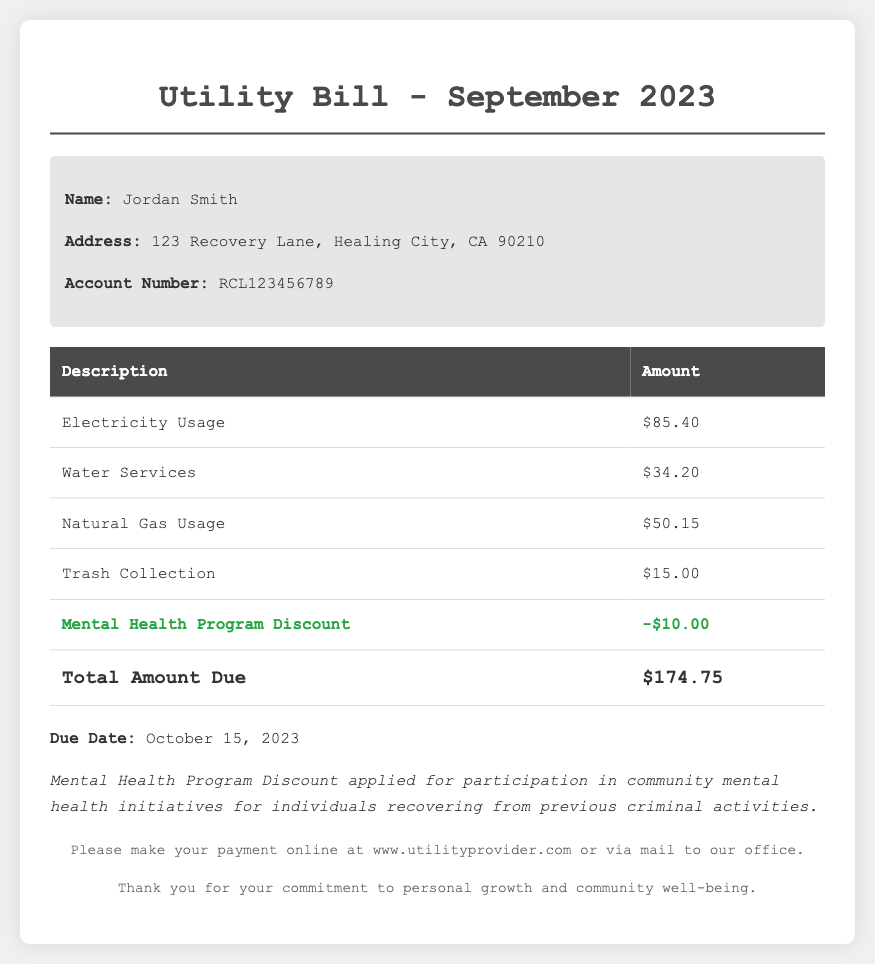What is the name of the account holder? The account holder's name is located in the customer info section.
Answer: Jordan Smith What is the address on the utility bill? The address can be found alongside the account holder's name.
Answer: 123 Recovery Lane, Healing City, CA 90210 What is the total amount due for the utility bill? The total amount due is highlighted in the total section of the document.
Answer: $174.75 What discount is applied to the bill? The document specifies the particular discount applied under the discount section.
Answer: Mental Health Program Discount How much is the Mental Health Program Discount? The amount for the discount can be found in the discount section at the end of the charges.
Answer: -$10.00 When is the payment due? The due date for the payment is stated in the bill.
Answer: October 15, 2023 What is included in the electricity usage charges? The electricity usage charge is listed in the charges section of the document.
Answer: $85.40 How many types of services are listed in the bill? The document lists all charges under the services provided, which indicates the number of service types included.
Answer: 4 What does the footnote suggest regarding mental health initiatives? The footnote gives information about the mental health initiative's benefits reflected in the bill.
Answer: Participation in community mental health initiatives for individuals recovering from previous criminal activities 